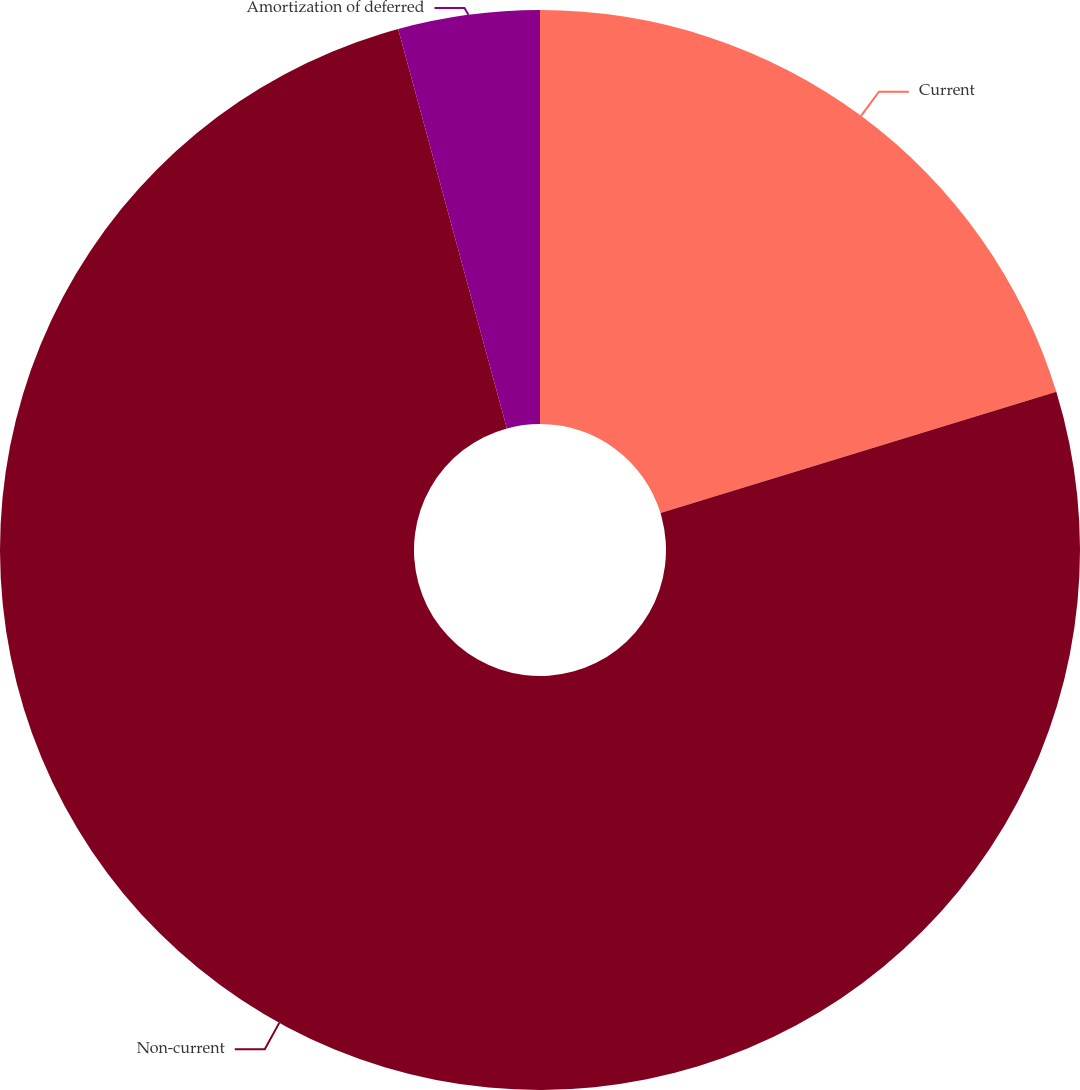Convert chart. <chart><loc_0><loc_0><loc_500><loc_500><pie_chart><fcel>Current<fcel>Non-current<fcel>Amortization of deferred<nl><fcel>20.27%<fcel>75.5%<fcel>4.23%<nl></chart> 